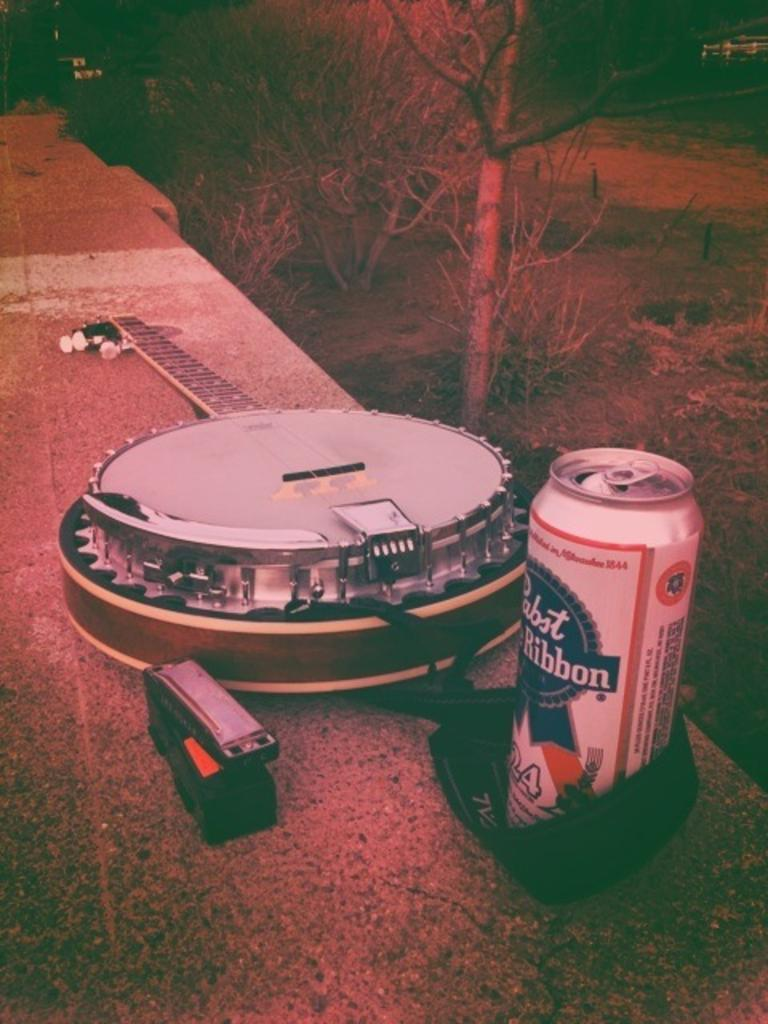<image>
Write a terse but informative summary of the picture. a can that has the word ribbon on it 